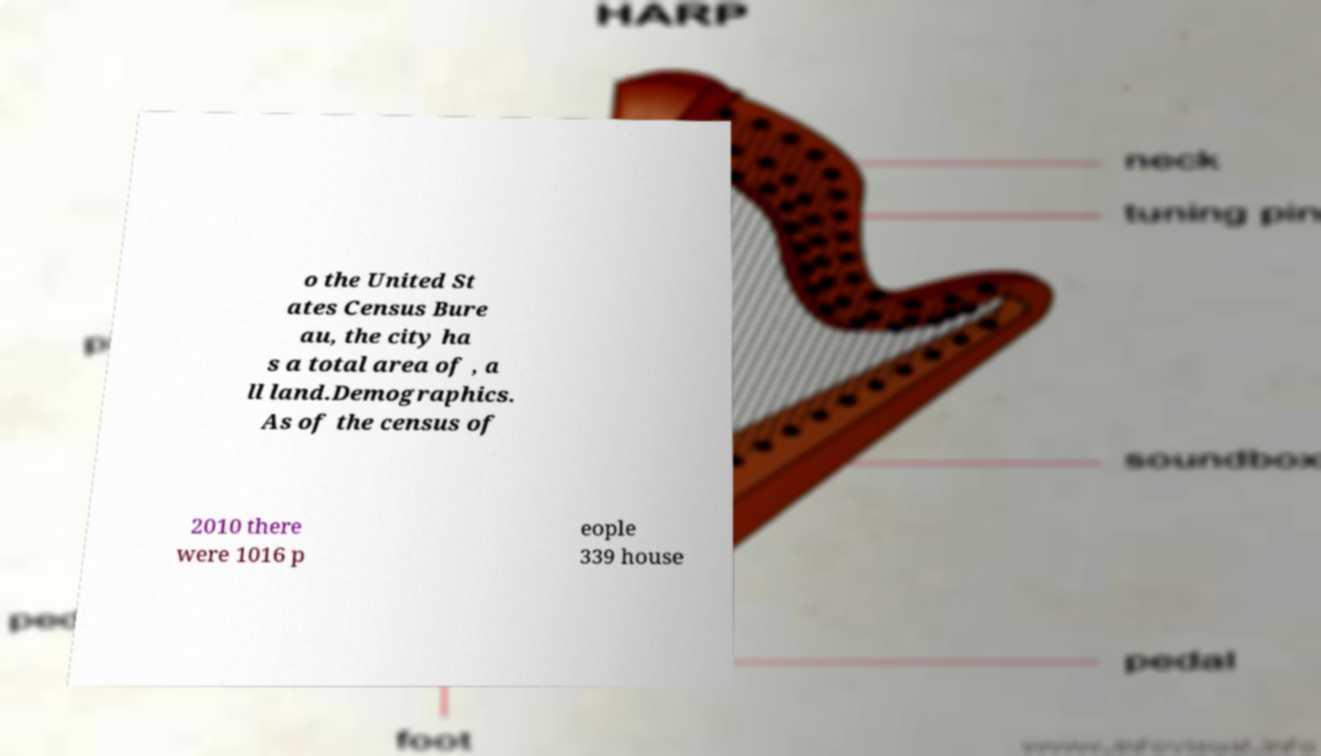Could you assist in decoding the text presented in this image and type it out clearly? o the United St ates Census Bure au, the city ha s a total area of , a ll land.Demographics. As of the census of 2010 there were 1016 p eople 339 house 